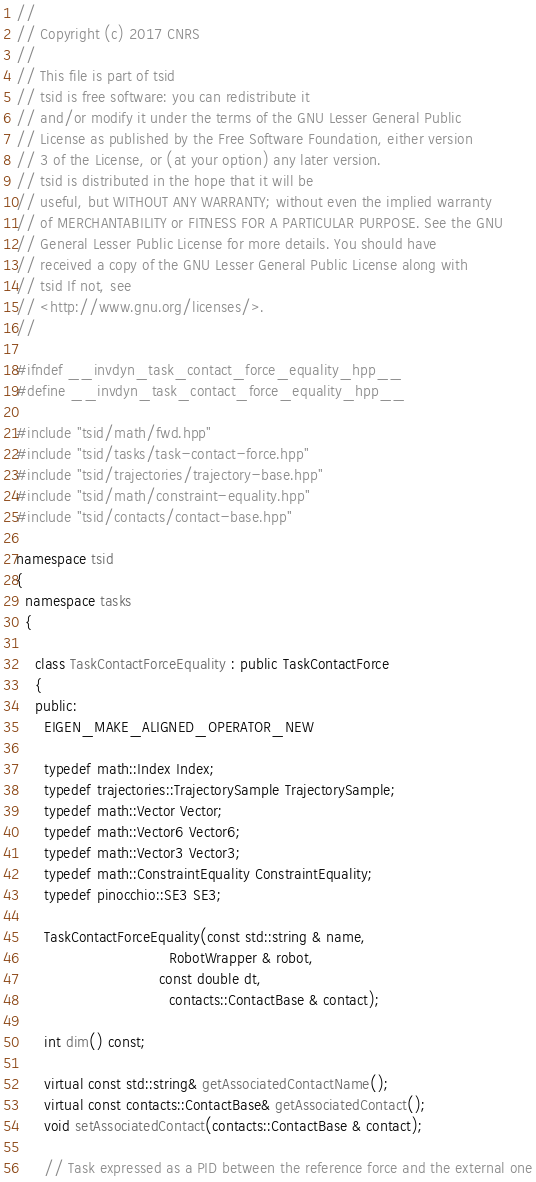<code> <loc_0><loc_0><loc_500><loc_500><_C++_>//
// Copyright (c) 2017 CNRS
//
// This file is part of tsid
// tsid is free software: you can redistribute it
// and/or modify it under the terms of the GNU Lesser General Public
// License as published by the Free Software Foundation, either version
// 3 of the License, or (at your option) any later version.
// tsid is distributed in the hope that it will be
// useful, but WITHOUT ANY WARRANTY; without even the implied warranty
// of MERCHANTABILITY or FITNESS FOR A PARTICULAR PURPOSE. See the GNU
// General Lesser Public License for more details. You should have
// received a copy of the GNU Lesser General Public License along with
// tsid If not, see
// <http://www.gnu.org/licenses/>.
//

#ifndef __invdyn_task_contact_force_equality_hpp__
#define __invdyn_task_contact_force_equality_hpp__

#include "tsid/math/fwd.hpp"
#include "tsid/tasks/task-contact-force.hpp"
#include "tsid/trajectories/trajectory-base.hpp"
#include "tsid/math/constraint-equality.hpp"
#include "tsid/contacts/contact-base.hpp"

namespace tsid
{
  namespace tasks
  {

    class TaskContactForceEquality : public TaskContactForce
    {
    public:
      EIGEN_MAKE_ALIGNED_OPERATOR_NEW

      typedef math::Index Index;
      typedef trajectories::TrajectorySample TrajectorySample;
      typedef math::Vector Vector;
      typedef math::Vector6 Vector6;
      typedef math::Vector3 Vector3;
      typedef math::ConstraintEquality ConstraintEquality;
      typedef pinocchio::SE3 SE3;

      TaskContactForceEquality(const std::string & name,
                      		     RobotWrapper & robot,
                               const double dt,
                      		     contacts::ContactBase & contact);

      int dim() const;

      virtual const std::string& getAssociatedContactName();
      virtual const contacts::ContactBase& getAssociatedContact();
      void setAssociatedContact(contacts::ContactBase & contact);

      // Task expressed as a PID between the reference force and the external one</code> 